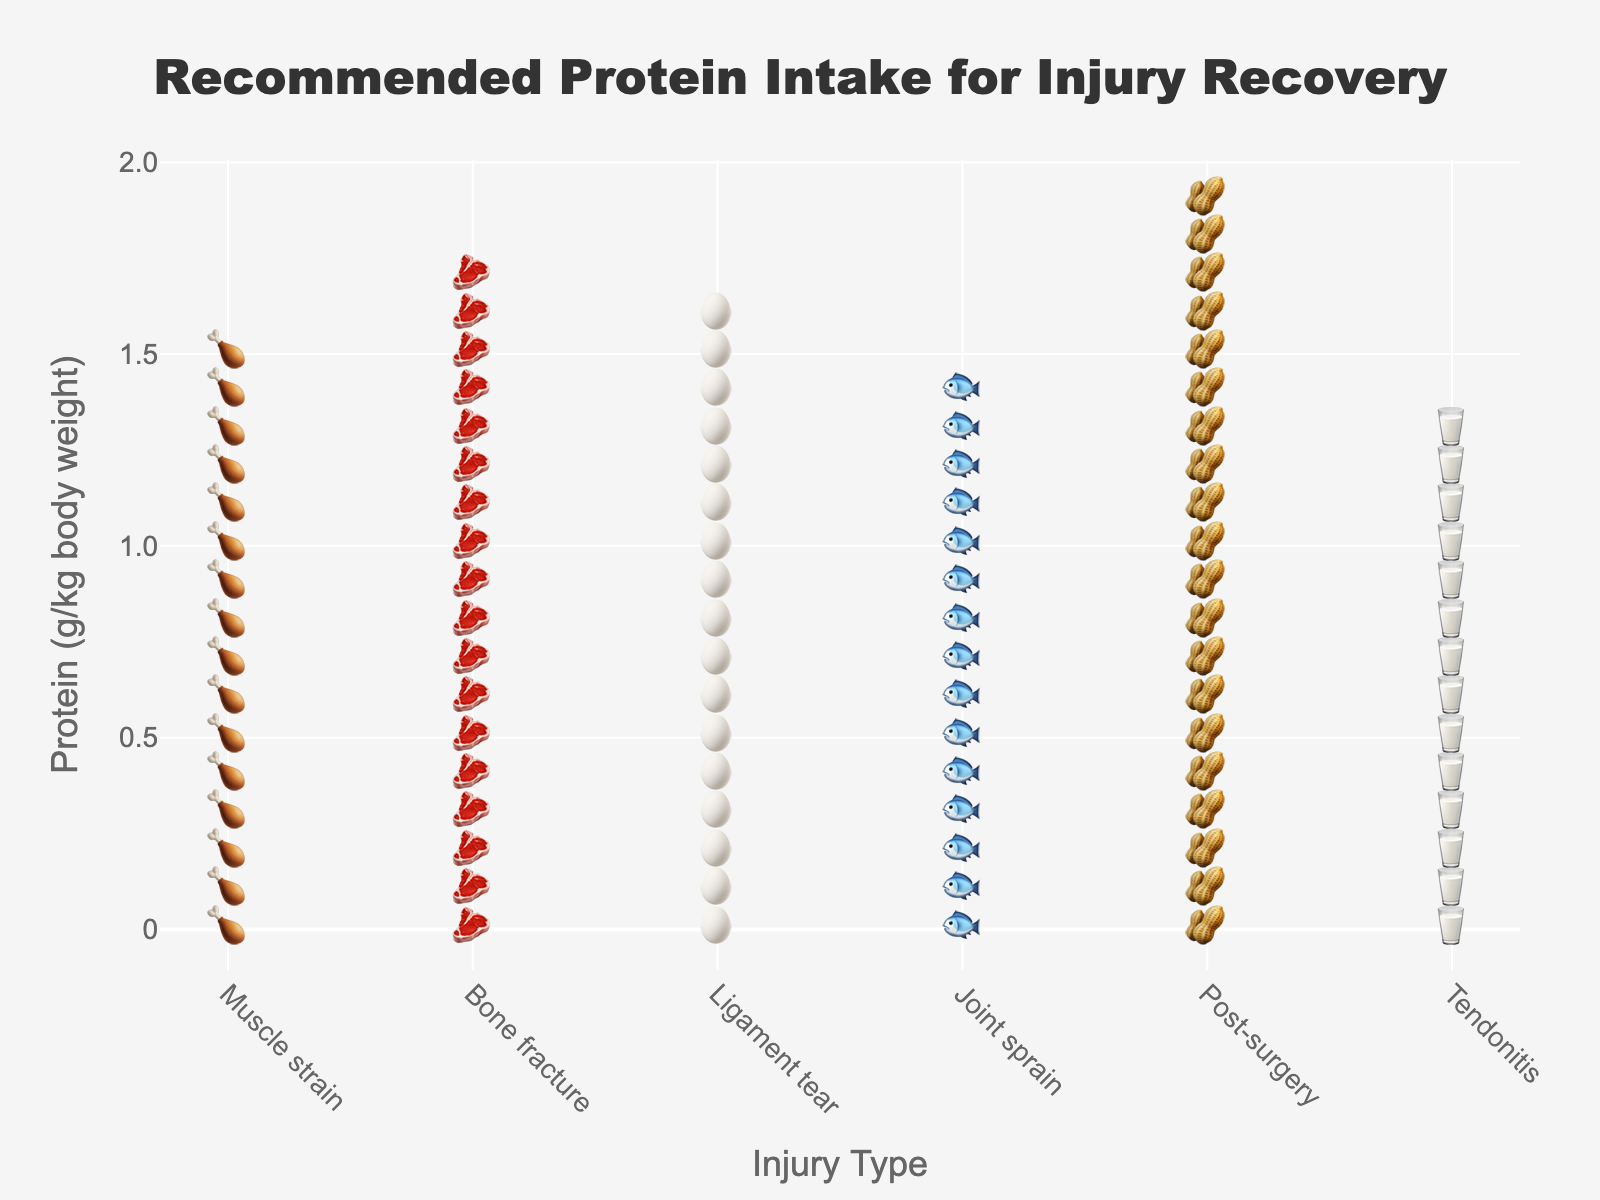What's the title of the figure? The title is usually the text at the top of the figure. In this case, it helps identify the content of the figure. The title here is "Recommended Protein Intake for Injury Recovery".
Answer: Recommended Protein Intake for Injury Recovery Which injury type has the highest recommended protein intake? To identify the highest recommended protein intake, look for the row with the most icons representing protein grams per kg. Here, "Post-surgery" has the highest count of icons.
Answer: Post-surgery How much protein is recommended for someone recovering from a joint sprain? Each icon represents 0.1 grams per kg of body weight. For "Joint sprain," there are 15 icons, which translates to 1.5 grams per kg.
Answer: 1.5 grams per kg How many types of injuries are listed in the figure? Count the number of distinct injury types shown on the x-axis of the plot. There are six types of injuries listed.
Answer: Six Which injury types have a recommended protein intake of more than 1.6 grams per kg? Identify all injury types with more than 16 icons (as each icon represents 0.1 grams). These are "Muscle strain," "Bone fracture," "Ligament tear," and "Post-surgery".
Answer: Muscle strain, Bone fracture, Ligament tear, Post-surgery What is the average recommended protein intake across all injury types? Add the protein intake values for all six injury types and divide by the number of types. (1.6 + 1.8 + 1.7 + 1.5 + 2.0 + 1.4) / 6 = 1.67 grams per kg.
Answer: 1.67 grams per kg Which injury type has the lowest recommended protein intake? Locate the row with the fewest icons, representing the lowest recommended protein grams per kg. "Tendonitis" has the fewest icons.
Answer: Tendonitis What is the difference in recommended protein intake between a bone fracture and tendonitis? Subtract the protein intake for "Tendonitis" from "Bone fracture". (1.8 - 1.4) = 0.4 grams per kg.
Answer: 0.4 grams per kg How many icons are associated with ligament tear? Count the number of icons for "Ligament tear" representing the protein intake. There are 17 icons.
Answer: 17 How does the recommended protein intake for muscle strain compare to that for joint sprain? Compare the number of icons for "Muscle strain" and "Joint sprain". Muscle strain has 16 icons and joint sprain has 15 icons, so muscle strain is higher.
Answer: Muscle strain is higher 